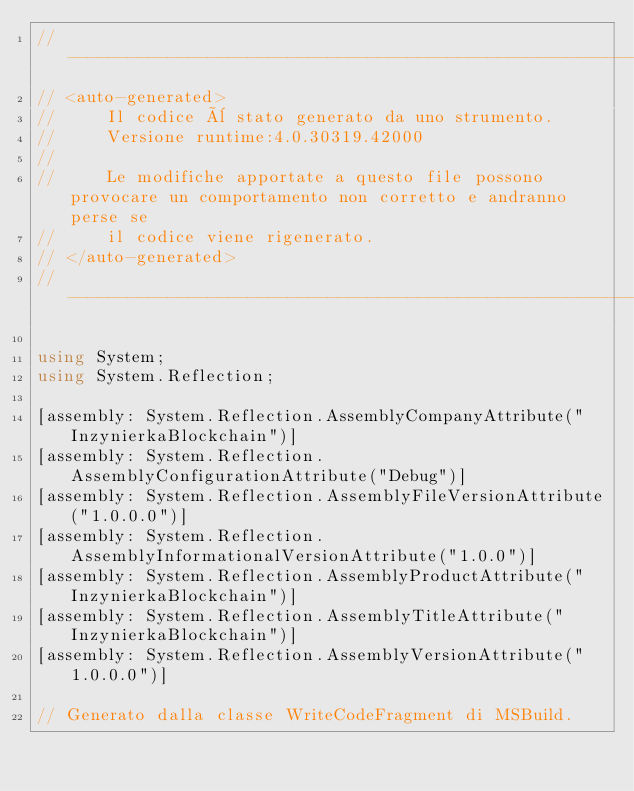Convert code to text. <code><loc_0><loc_0><loc_500><loc_500><_C#_>//------------------------------------------------------------------------------
// <auto-generated>
//     Il codice è stato generato da uno strumento.
//     Versione runtime:4.0.30319.42000
//
//     Le modifiche apportate a questo file possono provocare un comportamento non corretto e andranno perse se
//     il codice viene rigenerato.
// </auto-generated>
//------------------------------------------------------------------------------

using System;
using System.Reflection;

[assembly: System.Reflection.AssemblyCompanyAttribute("InzynierkaBlockchain")]
[assembly: System.Reflection.AssemblyConfigurationAttribute("Debug")]
[assembly: System.Reflection.AssemblyFileVersionAttribute("1.0.0.0")]
[assembly: System.Reflection.AssemblyInformationalVersionAttribute("1.0.0")]
[assembly: System.Reflection.AssemblyProductAttribute("InzynierkaBlockchain")]
[assembly: System.Reflection.AssemblyTitleAttribute("InzynierkaBlockchain")]
[assembly: System.Reflection.AssemblyVersionAttribute("1.0.0.0")]

// Generato dalla classe WriteCodeFragment di MSBuild.

</code> 